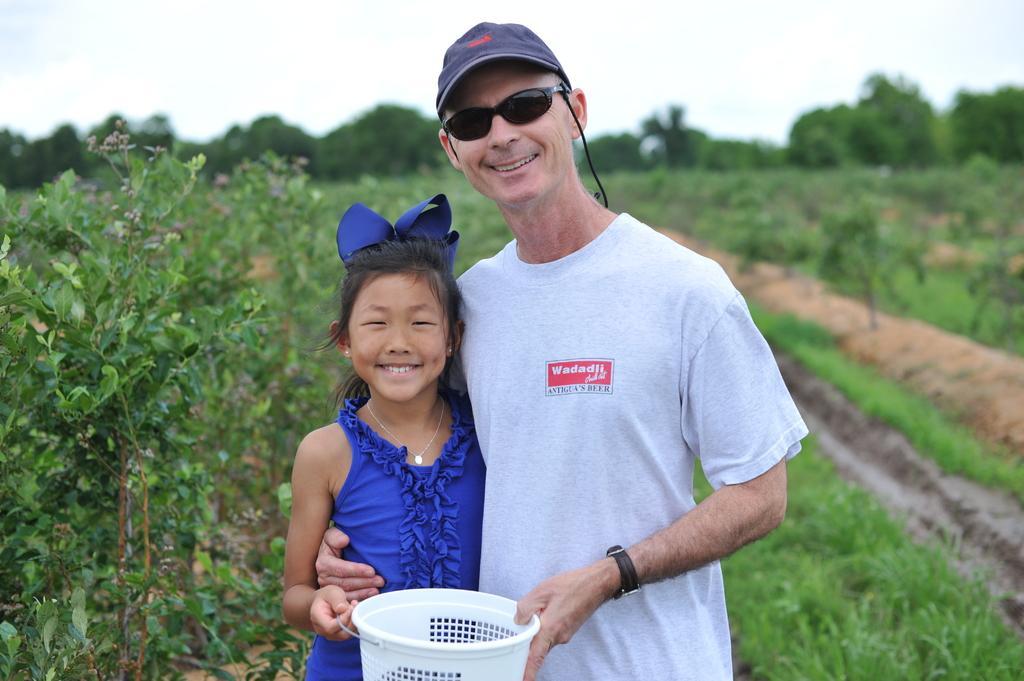Please provide a concise description of this image. In this picture there are two persons standing and smiling and holding the object. At the back there are trees. At the top there is sky. At the bottom there are plants and there is mud and there is grass. 